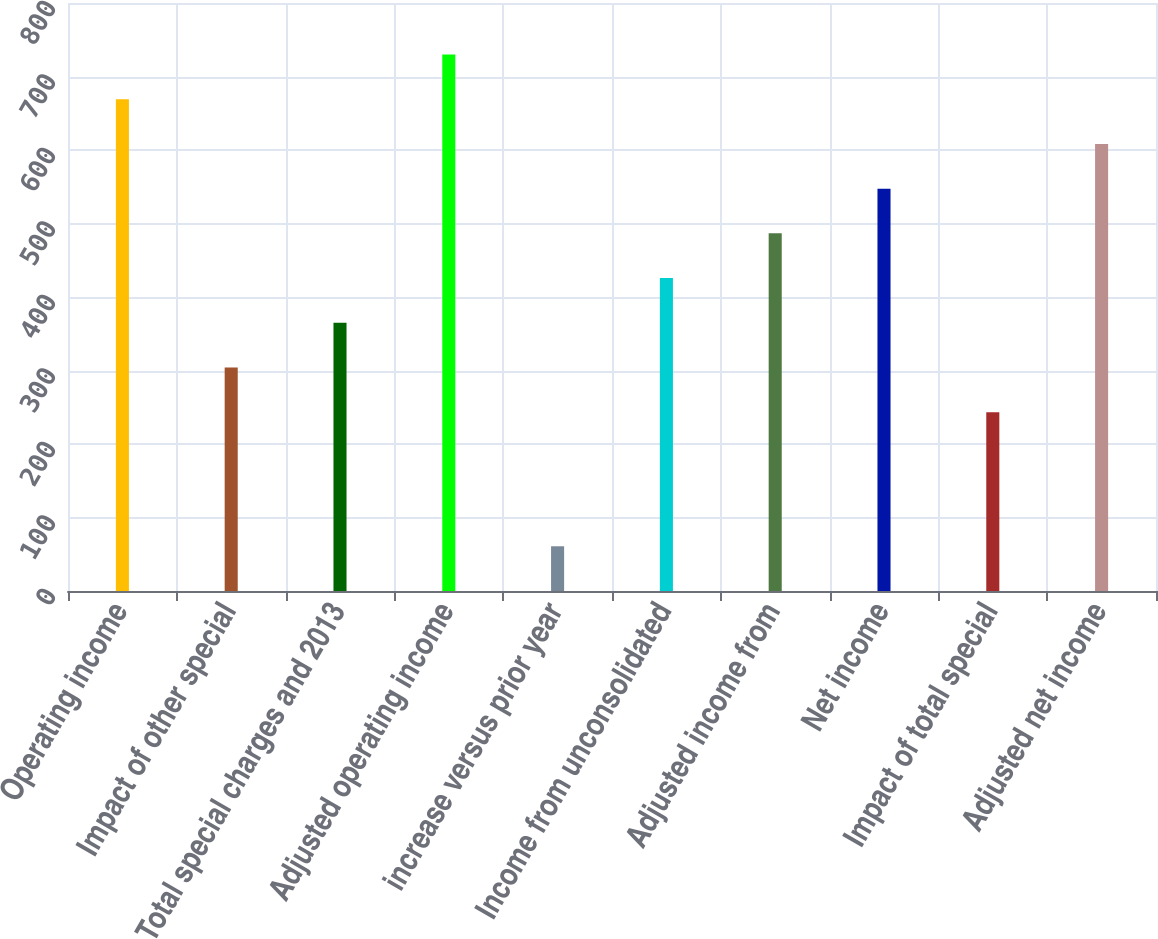Convert chart to OTSL. <chart><loc_0><loc_0><loc_500><loc_500><bar_chart><fcel>Operating income<fcel>Impact of other special<fcel>Total special charges and 2013<fcel>Adjusted operating income<fcel>increase versus prior year<fcel>Income from unconsolidated<fcel>Adjusted income from<fcel>Net income<fcel>Impact of total special<fcel>Adjusted net income<nl><fcel>669.05<fcel>304.13<fcel>364.95<fcel>729.87<fcel>60.85<fcel>425.77<fcel>486.59<fcel>547.41<fcel>243.31<fcel>608.23<nl></chart> 